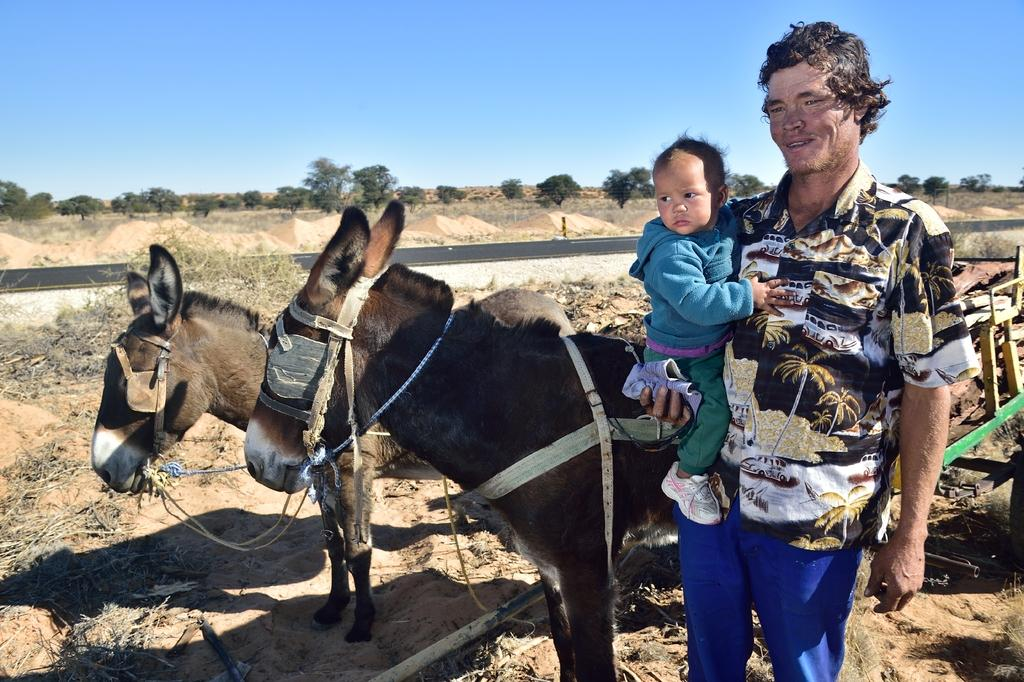What is the main subject of the image? There is a person standing in the image. What is the person doing in the image? The person is holding a kid in his hand. Where are the person and kid located in the image? They are in the right corner of the image. What other animals are present in the image? There are two donkeys beside the person. What can be seen in the background of the image? There are trees in the background of the image. What type of carriage is being pulled by the snail in the image? There is no carriage or snail present in the image. 